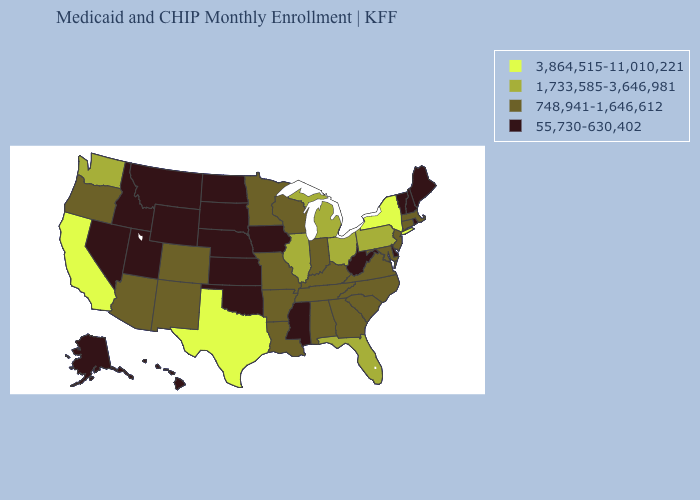What is the value of South Dakota?
Give a very brief answer. 55,730-630,402. What is the value of North Carolina?
Keep it brief. 748,941-1,646,612. Among the states that border Minnesota , which have the lowest value?
Concise answer only. Iowa, North Dakota, South Dakota. What is the lowest value in the USA?
Answer briefly. 55,730-630,402. Does the map have missing data?
Quick response, please. No. Does Vermont have the highest value in the USA?
Give a very brief answer. No. What is the value of Kansas?
Keep it brief. 55,730-630,402. Name the states that have a value in the range 748,941-1,646,612?
Quick response, please. Alabama, Arizona, Arkansas, Colorado, Connecticut, Georgia, Indiana, Kentucky, Louisiana, Maryland, Massachusetts, Minnesota, Missouri, New Jersey, New Mexico, North Carolina, Oregon, South Carolina, Tennessee, Virginia, Wisconsin. Does California have the highest value in the USA?
Short answer required. Yes. Name the states that have a value in the range 55,730-630,402?
Be succinct. Alaska, Delaware, Hawaii, Idaho, Iowa, Kansas, Maine, Mississippi, Montana, Nebraska, Nevada, New Hampshire, North Dakota, Oklahoma, Rhode Island, South Dakota, Utah, Vermont, West Virginia, Wyoming. Does Connecticut have the lowest value in the USA?
Short answer required. No. What is the highest value in the USA?
Short answer required. 3,864,515-11,010,221. What is the lowest value in the South?
Be succinct. 55,730-630,402. Which states have the lowest value in the South?
Concise answer only. Delaware, Mississippi, Oklahoma, West Virginia. 